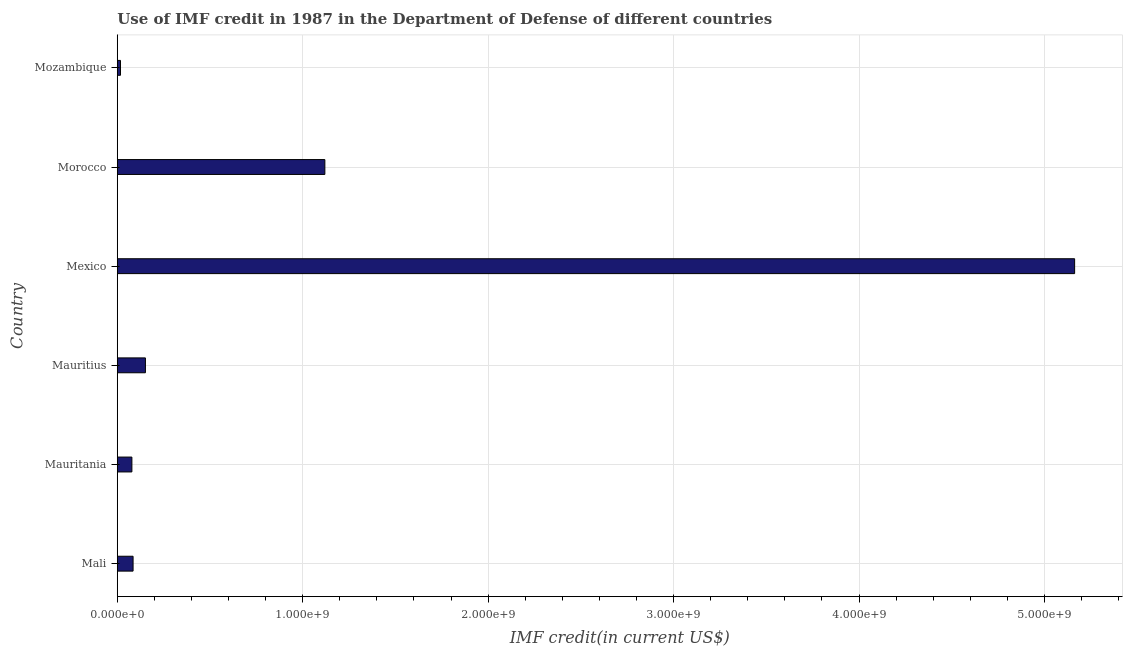Does the graph contain any zero values?
Your answer should be compact. No. Does the graph contain grids?
Make the answer very short. Yes. What is the title of the graph?
Provide a short and direct response. Use of IMF credit in 1987 in the Department of Defense of different countries. What is the label or title of the X-axis?
Your response must be concise. IMF credit(in current US$). What is the label or title of the Y-axis?
Provide a succinct answer. Country. What is the use of imf credit in dod in Mozambique?
Your answer should be very brief. 1.73e+07. Across all countries, what is the maximum use of imf credit in dod?
Your response must be concise. 5.16e+09. Across all countries, what is the minimum use of imf credit in dod?
Offer a very short reply. 1.73e+07. In which country was the use of imf credit in dod maximum?
Make the answer very short. Mexico. In which country was the use of imf credit in dod minimum?
Ensure brevity in your answer.  Mozambique. What is the sum of the use of imf credit in dod?
Give a very brief answer. 6.62e+09. What is the difference between the use of imf credit in dod in Mauritius and Mozambique?
Offer a terse response. 1.34e+08. What is the average use of imf credit in dod per country?
Give a very brief answer. 1.10e+09. What is the median use of imf credit in dod?
Give a very brief answer. 1.18e+08. In how many countries, is the use of imf credit in dod greater than 3000000000 US$?
Your answer should be very brief. 1. What is the ratio of the use of imf credit in dod in Morocco to that in Mozambique?
Keep it short and to the point. 64.68. Is the use of imf credit in dod in Mexico less than that in Morocco?
Your answer should be very brief. No. Is the difference between the use of imf credit in dod in Mali and Mozambique greater than the difference between any two countries?
Provide a short and direct response. No. What is the difference between the highest and the second highest use of imf credit in dod?
Your answer should be very brief. 4.04e+09. What is the difference between the highest and the lowest use of imf credit in dod?
Ensure brevity in your answer.  5.15e+09. In how many countries, is the use of imf credit in dod greater than the average use of imf credit in dod taken over all countries?
Make the answer very short. 2. Are all the bars in the graph horizontal?
Give a very brief answer. Yes. What is the IMF credit(in current US$) of Mali?
Ensure brevity in your answer.  8.52e+07. What is the IMF credit(in current US$) of Mauritania?
Offer a terse response. 7.88e+07. What is the IMF credit(in current US$) in Mauritius?
Your response must be concise. 1.52e+08. What is the IMF credit(in current US$) of Mexico?
Give a very brief answer. 5.16e+09. What is the IMF credit(in current US$) of Morocco?
Provide a short and direct response. 1.12e+09. What is the IMF credit(in current US$) of Mozambique?
Offer a very short reply. 1.73e+07. What is the difference between the IMF credit(in current US$) in Mali and Mauritania?
Offer a very short reply. 6.39e+06. What is the difference between the IMF credit(in current US$) in Mali and Mauritius?
Provide a succinct answer. -6.65e+07. What is the difference between the IMF credit(in current US$) in Mali and Mexico?
Your answer should be very brief. -5.08e+09. What is the difference between the IMF credit(in current US$) in Mali and Morocco?
Provide a succinct answer. -1.03e+09. What is the difference between the IMF credit(in current US$) in Mali and Mozambique?
Provide a short and direct response. 6.79e+07. What is the difference between the IMF credit(in current US$) in Mauritania and Mauritius?
Keep it short and to the point. -7.29e+07. What is the difference between the IMF credit(in current US$) in Mauritania and Mexico?
Your answer should be very brief. -5.08e+09. What is the difference between the IMF credit(in current US$) in Mauritania and Morocco?
Offer a terse response. -1.04e+09. What is the difference between the IMF credit(in current US$) in Mauritania and Mozambique?
Ensure brevity in your answer.  6.15e+07. What is the difference between the IMF credit(in current US$) in Mauritius and Mexico?
Your answer should be very brief. -5.01e+09. What is the difference between the IMF credit(in current US$) in Mauritius and Morocco?
Give a very brief answer. -9.68e+08. What is the difference between the IMF credit(in current US$) in Mauritius and Mozambique?
Your answer should be very brief. 1.34e+08. What is the difference between the IMF credit(in current US$) in Mexico and Morocco?
Make the answer very short. 4.04e+09. What is the difference between the IMF credit(in current US$) in Mexico and Mozambique?
Provide a short and direct response. 5.15e+09. What is the difference between the IMF credit(in current US$) in Morocco and Mozambique?
Your answer should be very brief. 1.10e+09. What is the ratio of the IMF credit(in current US$) in Mali to that in Mauritania?
Ensure brevity in your answer.  1.08. What is the ratio of the IMF credit(in current US$) in Mali to that in Mauritius?
Offer a very short reply. 0.56. What is the ratio of the IMF credit(in current US$) in Mali to that in Mexico?
Ensure brevity in your answer.  0.02. What is the ratio of the IMF credit(in current US$) in Mali to that in Morocco?
Offer a very short reply. 0.08. What is the ratio of the IMF credit(in current US$) in Mali to that in Mozambique?
Your answer should be compact. 4.92. What is the ratio of the IMF credit(in current US$) in Mauritania to that in Mauritius?
Your answer should be very brief. 0.52. What is the ratio of the IMF credit(in current US$) in Mauritania to that in Mexico?
Your answer should be compact. 0.01. What is the ratio of the IMF credit(in current US$) in Mauritania to that in Morocco?
Keep it short and to the point. 0.07. What is the ratio of the IMF credit(in current US$) in Mauritania to that in Mozambique?
Your answer should be compact. 4.55. What is the ratio of the IMF credit(in current US$) in Mauritius to that in Mexico?
Your answer should be compact. 0.03. What is the ratio of the IMF credit(in current US$) in Mauritius to that in Morocco?
Ensure brevity in your answer.  0.14. What is the ratio of the IMF credit(in current US$) in Mauritius to that in Mozambique?
Your answer should be very brief. 8.77. What is the ratio of the IMF credit(in current US$) in Mexico to that in Morocco?
Provide a short and direct response. 4.61. What is the ratio of the IMF credit(in current US$) in Mexico to that in Mozambique?
Offer a terse response. 298.29. What is the ratio of the IMF credit(in current US$) in Morocco to that in Mozambique?
Your answer should be compact. 64.68. 